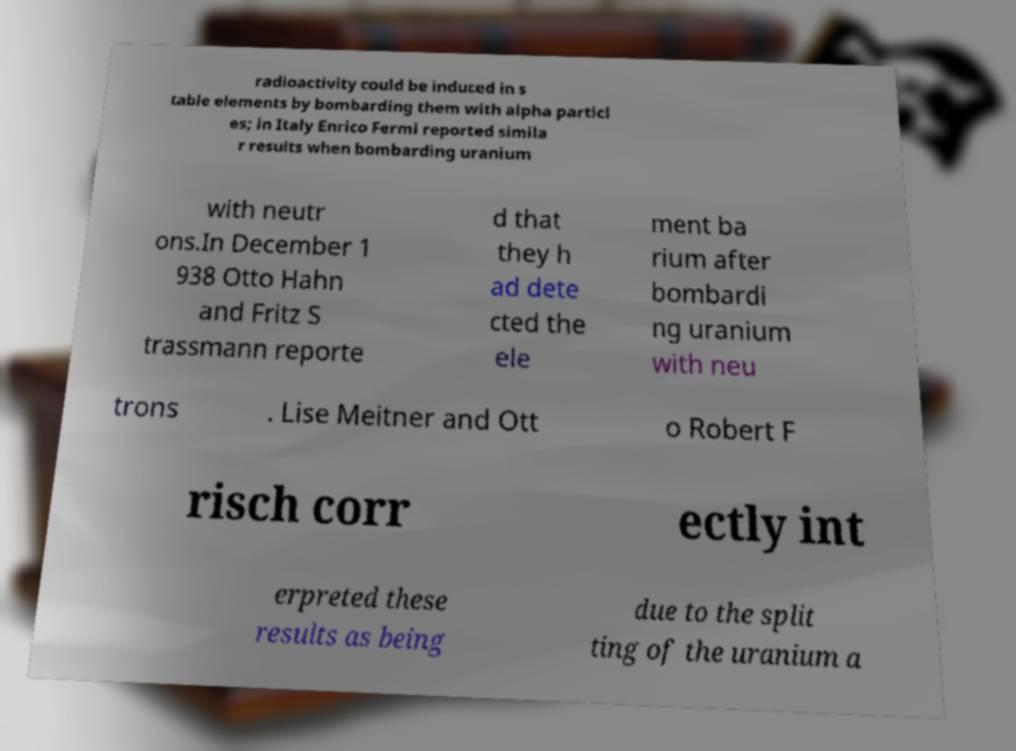Could you extract and type out the text from this image? radioactivity could be induced in s table elements by bombarding them with alpha particl es; in Italy Enrico Fermi reported simila r results when bombarding uranium with neutr ons.In December 1 938 Otto Hahn and Fritz S trassmann reporte d that they h ad dete cted the ele ment ba rium after bombardi ng uranium with neu trons . Lise Meitner and Ott o Robert F risch corr ectly int erpreted these results as being due to the split ting of the uranium a 